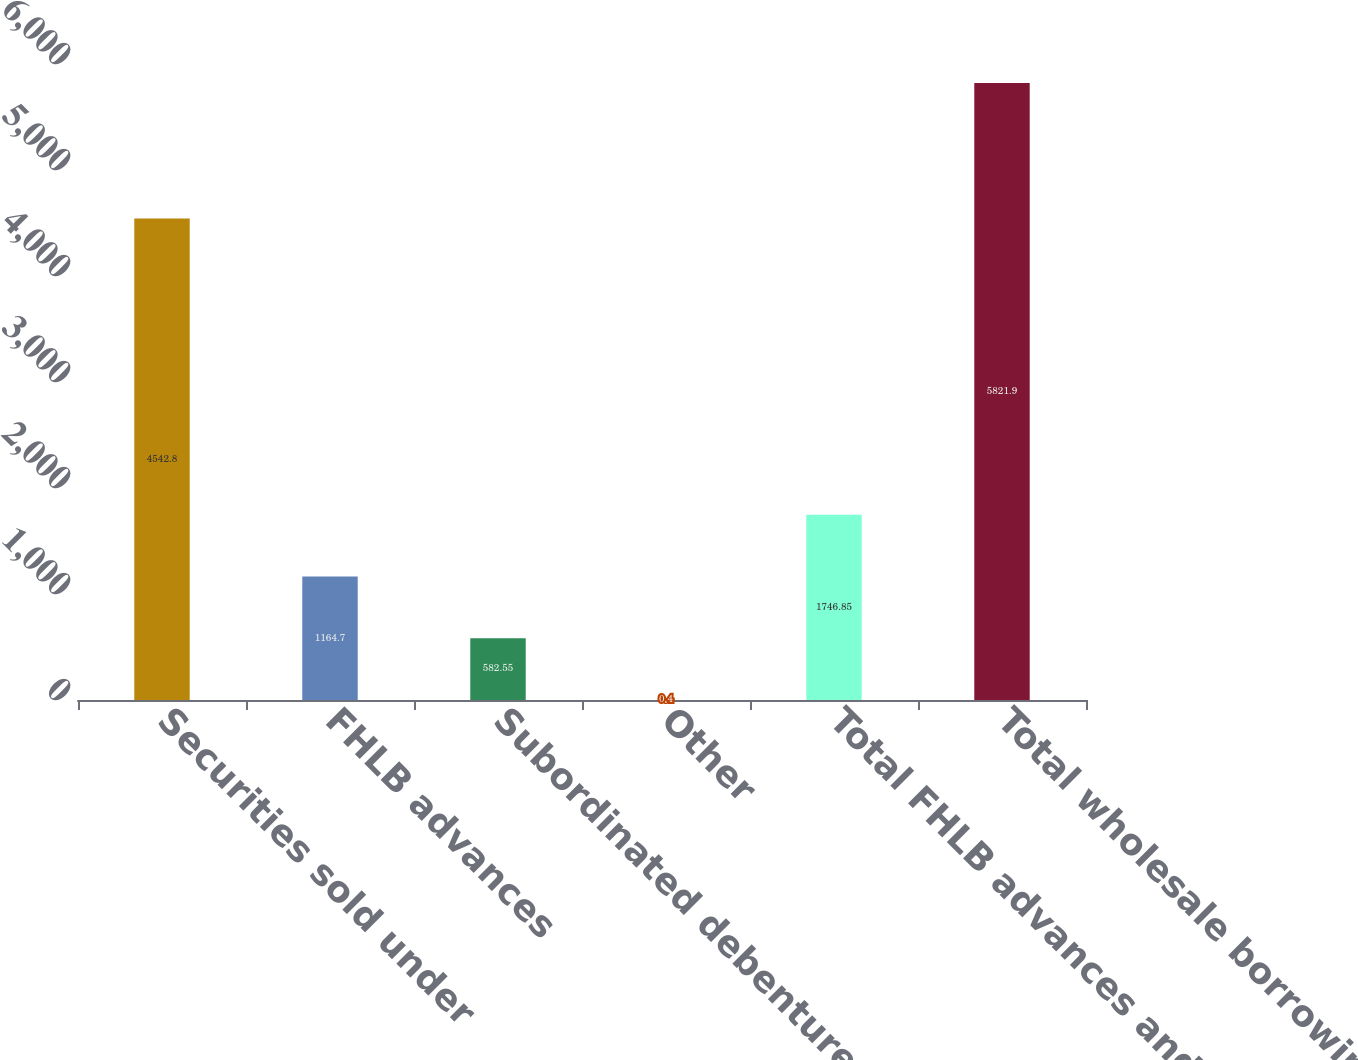Convert chart to OTSL. <chart><loc_0><loc_0><loc_500><loc_500><bar_chart><fcel>Securities sold under<fcel>FHLB advances<fcel>Subordinated debentures<fcel>Other<fcel>Total FHLB advances and other<fcel>Total wholesale borrowings<nl><fcel>4542.8<fcel>1164.7<fcel>582.55<fcel>0.4<fcel>1746.85<fcel>5821.9<nl></chart> 